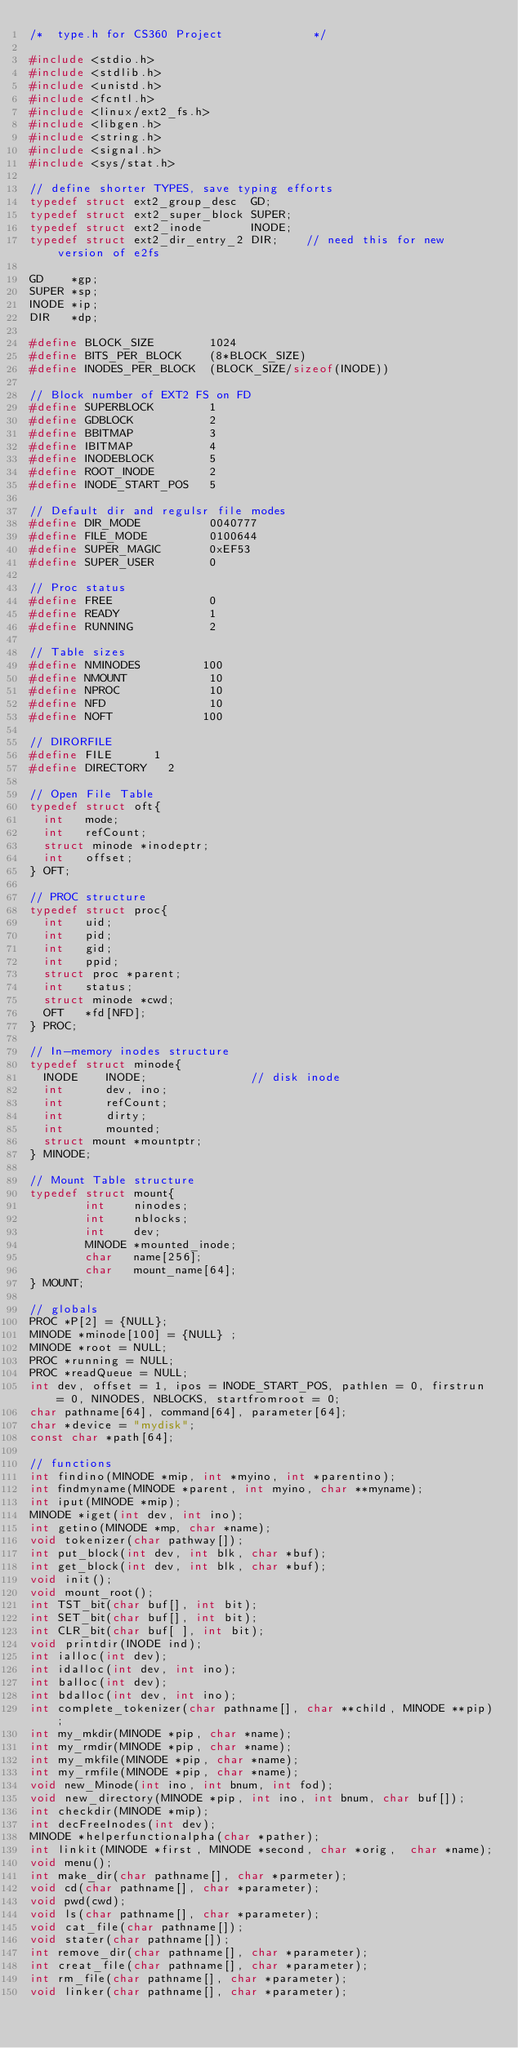Convert code to text. <code><loc_0><loc_0><loc_500><loc_500><_C_>/*	type.h for CS360 Project             */

#include <stdio.h>
#include <stdlib.h>
#include <unistd.h>
#include <fcntl.h>
#include <linux/ext2_fs.h>
#include <libgen.h>
#include <string.h>
#include <signal.h>
#include <sys/stat.h>

// define shorter TYPES, save typing efforts
typedef struct ext2_group_desc  GD;
typedef struct ext2_super_block SUPER;
typedef struct ext2_inode       INODE;
typedef struct ext2_dir_entry_2 DIR;    // need this for new version of e2fs

GD    *gp;
SUPER *sp;
INODE *ip;
DIR   *dp; 

#define BLOCK_SIZE        1024
#define BITS_PER_BLOCK    (8*BLOCK_SIZE)
#define INODES_PER_BLOCK  (BLOCK_SIZE/sizeof(INODE))

// Block number of EXT2 FS on FD
#define SUPERBLOCK        1
#define GDBLOCK           2
#define BBITMAP           3
#define IBITMAP           4
#define INODEBLOCK        5
#define ROOT_INODE        2
#define INODE_START_POS   5

// Default dir and regulsr file modes
#define DIR_MODE          0040777 
#define FILE_MODE         0100644
#define SUPER_MAGIC       0xEF53
#define SUPER_USER        0

// Proc status
#define FREE              0
#define READY             1
#define RUNNING           2

// Table sizes
#define NMINODES         100
#define NMOUNT            10
#define NPROC             10
#define NFD               10
#define NOFT             100

// DIRORFILE
#define FILE 			1
#define DIRECTORY		2

// Open File Table
typedef struct oft{
  int   mode;
  int   refCount;
  struct minode *inodeptr;
  int   offset;
} OFT;

// PROC structure
typedef struct proc{
  int   uid;
  int   pid;
  int   gid;
  int   ppid;
  struct proc *parent;
  int   status;
  struct minode *cwd;
  OFT   *fd[NFD];
} PROC;
      
// In-memory inodes structure
typedef struct minode{		
  INODE    INODE;               // disk inode
  int      dev, ino;
  int      refCount;
  int      dirty;
  int      mounted;
  struct mount *mountptr;
} MINODE;

// Mount Table structure
typedef struct mount{
        int    ninodes;
        int    nblocks;
        int    dev;
        MINODE *mounted_inode;
        char   name[256]; 
        char   mount_name[64];
} MOUNT;

// globals
PROC *P[2] = {NULL};
MINODE *minode[100] = {NULL} ;
MINODE *root = NULL;
PROC *running = NULL;
PROC *readQueue = NULL;
int dev, offset = 1, ipos = INODE_START_POS, pathlen = 0, firstrun = 0, NINODES, NBLOCKS, startfromroot = 0;
char pathname[64], command[64], parameter[64];
char *device = "mydisk";
const char *path[64];

// functions
int findino(MINODE *mip, int *myino, int *parentino);
int findmyname(MINODE *parent, int myino, char **myname);
int iput(MINODE *mip);
MINODE *iget(int dev, int ino);
int getino(MINODE *mp, char *name);
void tokenizer(char pathway[]);
int put_block(int dev, int blk, char *buf);
int get_block(int dev, int blk, char *buf);
void init();
void mount_root();
int TST_bit(char buf[], int bit);
int SET_bit(char buf[], int bit);
int CLR_bit(char buf[ ], int bit);
void printdir(INODE ind);
int ialloc(int dev);
int idalloc(int dev, int ino);
int balloc(int dev);
int bdalloc(int dev, int ino);
int complete_tokenizer(char pathname[], char **child, MINODE **pip);
int my_mkdir(MINODE *pip, char *name);
int my_rmdir(MINODE *pip, char *name);
int my_mkfile(MINODE *pip, char *name);
int my_rmfile(MINODE *pip, char *name);
void new_Minode(int ino, int bnum, int fod);
void new_directory(MINODE *pip, int ino, int bnum, char buf[]);
int checkdir(MINODE *mip);
int decFreeInodes(int dev);
MINODE *helperfunctionalpha(char *pather);
int linkit(MINODE *first, MINODE *second, char *orig,  char *name);
void menu();
int make_dir(char pathname[], char *parmeter);  
void cd(char pathname[], char *parameter);   
void pwd(cwd);
void ls(char pathname[], char *parameter);   
void cat_file(char pathname[]);   
void stater(char pathname[]);
int remove_dir(char pathname[], char *parameter);
int creat_file(char pathname[], char *parameter);
int rm_file(char pathname[], char *parameter);
void linker(char pathname[], char *parameter);</code> 